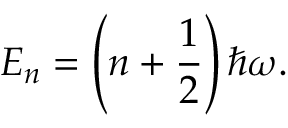Convert formula to latex. <formula><loc_0><loc_0><loc_500><loc_500>E _ { n } = \left ( n + { \frac { 1 } { 2 } } \right ) \hbar { \omega } .</formula> 